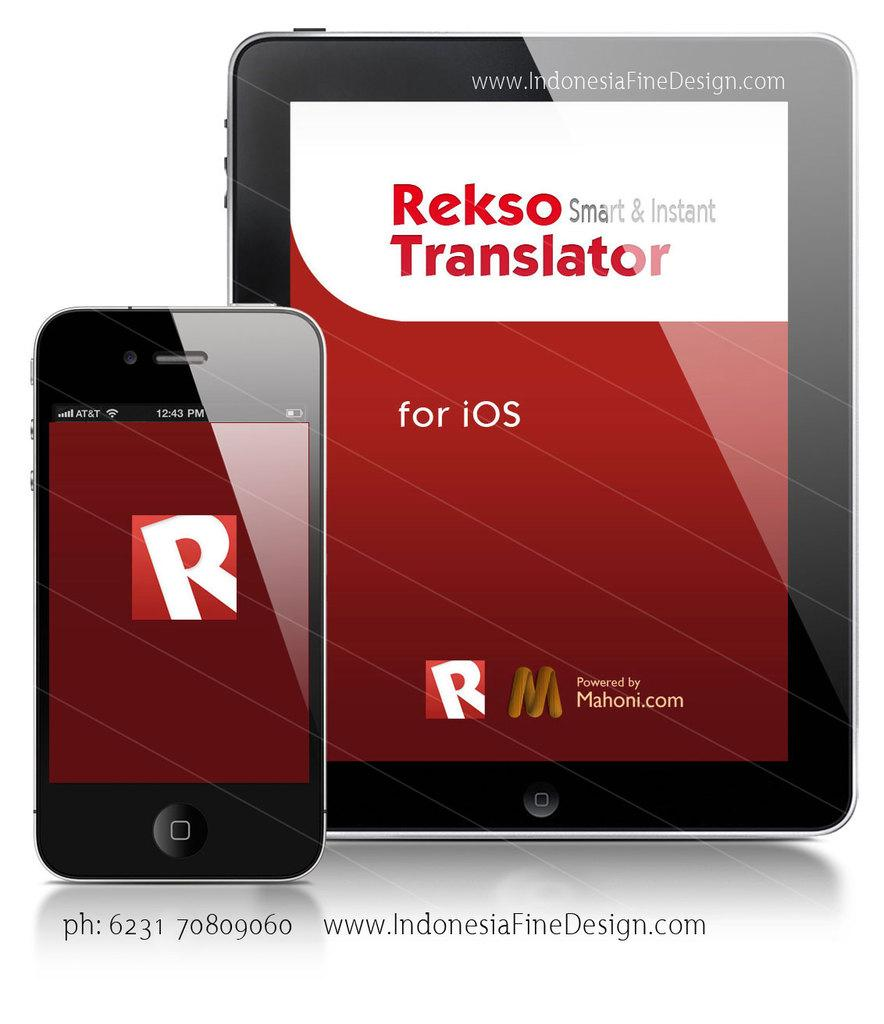<image>
Render a clear and concise summary of the photo. an iphone in front of an ipad that says 'rekso smart & instant translator' onit 